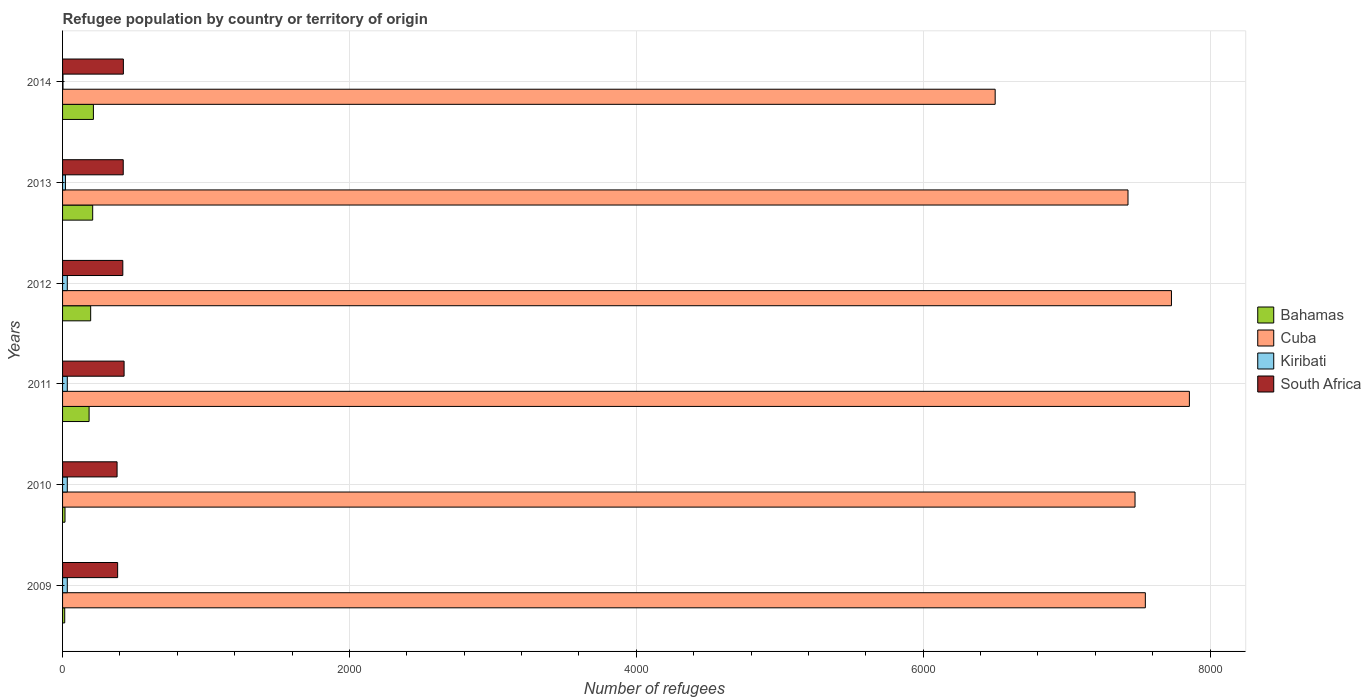How many groups of bars are there?
Offer a terse response. 6. Are the number of bars per tick equal to the number of legend labels?
Give a very brief answer. Yes. How many bars are there on the 4th tick from the bottom?
Give a very brief answer. 4. What is the label of the 2nd group of bars from the top?
Your answer should be compact. 2013. In how many cases, is the number of bars for a given year not equal to the number of legend labels?
Your answer should be very brief. 0. What is the number of refugees in South Africa in 2014?
Keep it short and to the point. 424. Across all years, what is the maximum number of refugees in Bahamas?
Make the answer very short. 215. Across all years, what is the minimum number of refugees in Cuba?
Your answer should be very brief. 6502. In which year was the number of refugees in Bahamas maximum?
Provide a short and direct response. 2014. What is the total number of refugees in Kiribati in the graph?
Keep it short and to the point. 155. What is the difference between the number of refugees in Bahamas in 2009 and that in 2010?
Your answer should be very brief. -2. What is the difference between the number of refugees in Cuba in 2014 and the number of refugees in Bahamas in 2013?
Ensure brevity in your answer.  6292. What is the average number of refugees in Cuba per year?
Your response must be concise. 7423.83. In the year 2012, what is the difference between the number of refugees in Kiribati and number of refugees in Bahamas?
Your answer should be compact. -163. In how many years, is the number of refugees in South Africa greater than 800 ?
Ensure brevity in your answer.  0. What is the ratio of the number of refugees in South Africa in 2009 to that in 2011?
Keep it short and to the point. 0.9. What is the difference between the highest and the second highest number of refugees in Cuba?
Ensure brevity in your answer.  125. What is the difference between the highest and the lowest number of refugees in South Africa?
Give a very brief answer. 49. In how many years, is the number of refugees in Kiribati greater than the average number of refugees in Kiribati taken over all years?
Provide a succinct answer. 4. What does the 2nd bar from the top in 2013 represents?
Provide a short and direct response. Kiribati. What does the 4th bar from the bottom in 2014 represents?
Offer a terse response. South Africa. Is it the case that in every year, the sum of the number of refugees in Cuba and number of refugees in South Africa is greater than the number of refugees in Bahamas?
Provide a succinct answer. Yes. What is the difference between two consecutive major ticks on the X-axis?
Make the answer very short. 2000. Does the graph contain any zero values?
Offer a terse response. No. Where does the legend appear in the graph?
Keep it short and to the point. Center right. How many legend labels are there?
Provide a short and direct response. 4. What is the title of the graph?
Your response must be concise. Refugee population by country or territory of origin. What is the label or title of the X-axis?
Give a very brief answer. Number of refugees. What is the Number of refugees in Bahamas in 2009?
Provide a short and direct response. 15. What is the Number of refugees in Cuba in 2009?
Provide a succinct answer. 7549. What is the Number of refugees in Kiribati in 2009?
Offer a terse response. 33. What is the Number of refugees of South Africa in 2009?
Provide a short and direct response. 384. What is the Number of refugees of Bahamas in 2010?
Provide a short and direct response. 17. What is the Number of refugees of Cuba in 2010?
Give a very brief answer. 7477. What is the Number of refugees in Kiribati in 2010?
Your answer should be compact. 33. What is the Number of refugees of South Africa in 2010?
Your answer should be very brief. 380. What is the Number of refugees in Bahamas in 2011?
Make the answer very short. 185. What is the Number of refugees in Cuba in 2011?
Ensure brevity in your answer.  7856. What is the Number of refugees in South Africa in 2011?
Provide a succinct answer. 429. What is the Number of refugees in Bahamas in 2012?
Give a very brief answer. 196. What is the Number of refugees in Cuba in 2012?
Give a very brief answer. 7731. What is the Number of refugees in South Africa in 2012?
Provide a succinct answer. 420. What is the Number of refugees of Bahamas in 2013?
Your answer should be very brief. 210. What is the Number of refugees of Cuba in 2013?
Provide a short and direct response. 7428. What is the Number of refugees of South Africa in 2013?
Make the answer very short. 423. What is the Number of refugees in Bahamas in 2014?
Provide a short and direct response. 215. What is the Number of refugees in Cuba in 2014?
Provide a succinct answer. 6502. What is the Number of refugees in Kiribati in 2014?
Keep it short and to the point. 3. What is the Number of refugees of South Africa in 2014?
Offer a terse response. 424. Across all years, what is the maximum Number of refugees in Bahamas?
Give a very brief answer. 215. Across all years, what is the maximum Number of refugees in Cuba?
Your answer should be very brief. 7856. Across all years, what is the maximum Number of refugees in South Africa?
Provide a succinct answer. 429. Across all years, what is the minimum Number of refugees of Cuba?
Your answer should be compact. 6502. Across all years, what is the minimum Number of refugees of South Africa?
Offer a terse response. 380. What is the total Number of refugees in Bahamas in the graph?
Your answer should be very brief. 838. What is the total Number of refugees of Cuba in the graph?
Provide a succinct answer. 4.45e+04. What is the total Number of refugees in Kiribati in the graph?
Provide a succinct answer. 155. What is the total Number of refugees in South Africa in the graph?
Your response must be concise. 2460. What is the difference between the Number of refugees of Kiribati in 2009 and that in 2010?
Offer a very short reply. 0. What is the difference between the Number of refugees in South Africa in 2009 and that in 2010?
Give a very brief answer. 4. What is the difference between the Number of refugees of Bahamas in 2009 and that in 2011?
Your response must be concise. -170. What is the difference between the Number of refugees of Cuba in 2009 and that in 2011?
Provide a succinct answer. -307. What is the difference between the Number of refugees of South Africa in 2009 and that in 2011?
Provide a short and direct response. -45. What is the difference between the Number of refugees in Bahamas in 2009 and that in 2012?
Offer a very short reply. -181. What is the difference between the Number of refugees in Cuba in 2009 and that in 2012?
Make the answer very short. -182. What is the difference between the Number of refugees in South Africa in 2009 and that in 2012?
Ensure brevity in your answer.  -36. What is the difference between the Number of refugees of Bahamas in 2009 and that in 2013?
Offer a terse response. -195. What is the difference between the Number of refugees in Cuba in 2009 and that in 2013?
Make the answer very short. 121. What is the difference between the Number of refugees in Kiribati in 2009 and that in 2013?
Provide a short and direct response. 13. What is the difference between the Number of refugees of South Africa in 2009 and that in 2013?
Ensure brevity in your answer.  -39. What is the difference between the Number of refugees of Bahamas in 2009 and that in 2014?
Give a very brief answer. -200. What is the difference between the Number of refugees of Cuba in 2009 and that in 2014?
Make the answer very short. 1047. What is the difference between the Number of refugees of Kiribati in 2009 and that in 2014?
Provide a succinct answer. 30. What is the difference between the Number of refugees in Bahamas in 2010 and that in 2011?
Offer a very short reply. -168. What is the difference between the Number of refugees in Cuba in 2010 and that in 2011?
Your answer should be very brief. -379. What is the difference between the Number of refugees in South Africa in 2010 and that in 2011?
Your answer should be very brief. -49. What is the difference between the Number of refugees of Bahamas in 2010 and that in 2012?
Your response must be concise. -179. What is the difference between the Number of refugees in Cuba in 2010 and that in 2012?
Offer a terse response. -254. What is the difference between the Number of refugees of South Africa in 2010 and that in 2012?
Ensure brevity in your answer.  -40. What is the difference between the Number of refugees of Bahamas in 2010 and that in 2013?
Your answer should be compact. -193. What is the difference between the Number of refugees of Cuba in 2010 and that in 2013?
Give a very brief answer. 49. What is the difference between the Number of refugees of South Africa in 2010 and that in 2013?
Offer a very short reply. -43. What is the difference between the Number of refugees in Bahamas in 2010 and that in 2014?
Ensure brevity in your answer.  -198. What is the difference between the Number of refugees of Cuba in 2010 and that in 2014?
Give a very brief answer. 975. What is the difference between the Number of refugees in Kiribati in 2010 and that in 2014?
Keep it short and to the point. 30. What is the difference between the Number of refugees in South Africa in 2010 and that in 2014?
Provide a succinct answer. -44. What is the difference between the Number of refugees in Cuba in 2011 and that in 2012?
Provide a succinct answer. 125. What is the difference between the Number of refugees in Bahamas in 2011 and that in 2013?
Keep it short and to the point. -25. What is the difference between the Number of refugees of Cuba in 2011 and that in 2013?
Offer a very short reply. 428. What is the difference between the Number of refugees of Kiribati in 2011 and that in 2013?
Make the answer very short. 13. What is the difference between the Number of refugees in South Africa in 2011 and that in 2013?
Offer a very short reply. 6. What is the difference between the Number of refugees in Bahamas in 2011 and that in 2014?
Offer a very short reply. -30. What is the difference between the Number of refugees of Cuba in 2011 and that in 2014?
Provide a short and direct response. 1354. What is the difference between the Number of refugees in South Africa in 2011 and that in 2014?
Provide a succinct answer. 5. What is the difference between the Number of refugees in Bahamas in 2012 and that in 2013?
Ensure brevity in your answer.  -14. What is the difference between the Number of refugees in Cuba in 2012 and that in 2013?
Keep it short and to the point. 303. What is the difference between the Number of refugees of South Africa in 2012 and that in 2013?
Offer a very short reply. -3. What is the difference between the Number of refugees of Bahamas in 2012 and that in 2014?
Your response must be concise. -19. What is the difference between the Number of refugees of Cuba in 2012 and that in 2014?
Your response must be concise. 1229. What is the difference between the Number of refugees of Kiribati in 2012 and that in 2014?
Provide a succinct answer. 30. What is the difference between the Number of refugees in South Africa in 2012 and that in 2014?
Your answer should be compact. -4. What is the difference between the Number of refugees of Cuba in 2013 and that in 2014?
Give a very brief answer. 926. What is the difference between the Number of refugees in Bahamas in 2009 and the Number of refugees in Cuba in 2010?
Offer a very short reply. -7462. What is the difference between the Number of refugees in Bahamas in 2009 and the Number of refugees in Kiribati in 2010?
Give a very brief answer. -18. What is the difference between the Number of refugees in Bahamas in 2009 and the Number of refugees in South Africa in 2010?
Your answer should be compact. -365. What is the difference between the Number of refugees in Cuba in 2009 and the Number of refugees in Kiribati in 2010?
Ensure brevity in your answer.  7516. What is the difference between the Number of refugees in Cuba in 2009 and the Number of refugees in South Africa in 2010?
Your answer should be very brief. 7169. What is the difference between the Number of refugees of Kiribati in 2009 and the Number of refugees of South Africa in 2010?
Make the answer very short. -347. What is the difference between the Number of refugees in Bahamas in 2009 and the Number of refugees in Cuba in 2011?
Offer a terse response. -7841. What is the difference between the Number of refugees in Bahamas in 2009 and the Number of refugees in Kiribati in 2011?
Provide a short and direct response. -18. What is the difference between the Number of refugees of Bahamas in 2009 and the Number of refugees of South Africa in 2011?
Ensure brevity in your answer.  -414. What is the difference between the Number of refugees in Cuba in 2009 and the Number of refugees in Kiribati in 2011?
Offer a terse response. 7516. What is the difference between the Number of refugees of Cuba in 2009 and the Number of refugees of South Africa in 2011?
Your answer should be compact. 7120. What is the difference between the Number of refugees in Kiribati in 2009 and the Number of refugees in South Africa in 2011?
Provide a succinct answer. -396. What is the difference between the Number of refugees in Bahamas in 2009 and the Number of refugees in Cuba in 2012?
Offer a very short reply. -7716. What is the difference between the Number of refugees of Bahamas in 2009 and the Number of refugees of Kiribati in 2012?
Offer a terse response. -18. What is the difference between the Number of refugees of Bahamas in 2009 and the Number of refugees of South Africa in 2012?
Offer a terse response. -405. What is the difference between the Number of refugees of Cuba in 2009 and the Number of refugees of Kiribati in 2012?
Provide a succinct answer. 7516. What is the difference between the Number of refugees in Cuba in 2009 and the Number of refugees in South Africa in 2012?
Provide a short and direct response. 7129. What is the difference between the Number of refugees in Kiribati in 2009 and the Number of refugees in South Africa in 2012?
Give a very brief answer. -387. What is the difference between the Number of refugees in Bahamas in 2009 and the Number of refugees in Cuba in 2013?
Offer a very short reply. -7413. What is the difference between the Number of refugees of Bahamas in 2009 and the Number of refugees of Kiribati in 2013?
Provide a succinct answer. -5. What is the difference between the Number of refugees in Bahamas in 2009 and the Number of refugees in South Africa in 2013?
Your response must be concise. -408. What is the difference between the Number of refugees of Cuba in 2009 and the Number of refugees of Kiribati in 2013?
Your answer should be compact. 7529. What is the difference between the Number of refugees in Cuba in 2009 and the Number of refugees in South Africa in 2013?
Provide a succinct answer. 7126. What is the difference between the Number of refugees in Kiribati in 2009 and the Number of refugees in South Africa in 2013?
Make the answer very short. -390. What is the difference between the Number of refugees in Bahamas in 2009 and the Number of refugees in Cuba in 2014?
Give a very brief answer. -6487. What is the difference between the Number of refugees of Bahamas in 2009 and the Number of refugees of Kiribati in 2014?
Your answer should be compact. 12. What is the difference between the Number of refugees of Bahamas in 2009 and the Number of refugees of South Africa in 2014?
Offer a very short reply. -409. What is the difference between the Number of refugees in Cuba in 2009 and the Number of refugees in Kiribati in 2014?
Provide a succinct answer. 7546. What is the difference between the Number of refugees in Cuba in 2009 and the Number of refugees in South Africa in 2014?
Keep it short and to the point. 7125. What is the difference between the Number of refugees of Kiribati in 2009 and the Number of refugees of South Africa in 2014?
Give a very brief answer. -391. What is the difference between the Number of refugees in Bahamas in 2010 and the Number of refugees in Cuba in 2011?
Your answer should be very brief. -7839. What is the difference between the Number of refugees in Bahamas in 2010 and the Number of refugees in South Africa in 2011?
Make the answer very short. -412. What is the difference between the Number of refugees in Cuba in 2010 and the Number of refugees in Kiribati in 2011?
Ensure brevity in your answer.  7444. What is the difference between the Number of refugees in Cuba in 2010 and the Number of refugees in South Africa in 2011?
Provide a short and direct response. 7048. What is the difference between the Number of refugees in Kiribati in 2010 and the Number of refugees in South Africa in 2011?
Your response must be concise. -396. What is the difference between the Number of refugees of Bahamas in 2010 and the Number of refugees of Cuba in 2012?
Your response must be concise. -7714. What is the difference between the Number of refugees in Bahamas in 2010 and the Number of refugees in Kiribati in 2012?
Provide a succinct answer. -16. What is the difference between the Number of refugees in Bahamas in 2010 and the Number of refugees in South Africa in 2012?
Provide a short and direct response. -403. What is the difference between the Number of refugees in Cuba in 2010 and the Number of refugees in Kiribati in 2012?
Your answer should be compact. 7444. What is the difference between the Number of refugees of Cuba in 2010 and the Number of refugees of South Africa in 2012?
Ensure brevity in your answer.  7057. What is the difference between the Number of refugees in Kiribati in 2010 and the Number of refugees in South Africa in 2012?
Provide a short and direct response. -387. What is the difference between the Number of refugees in Bahamas in 2010 and the Number of refugees in Cuba in 2013?
Your answer should be very brief. -7411. What is the difference between the Number of refugees of Bahamas in 2010 and the Number of refugees of Kiribati in 2013?
Your answer should be very brief. -3. What is the difference between the Number of refugees in Bahamas in 2010 and the Number of refugees in South Africa in 2013?
Your response must be concise. -406. What is the difference between the Number of refugees of Cuba in 2010 and the Number of refugees of Kiribati in 2013?
Your answer should be compact. 7457. What is the difference between the Number of refugees in Cuba in 2010 and the Number of refugees in South Africa in 2013?
Keep it short and to the point. 7054. What is the difference between the Number of refugees of Kiribati in 2010 and the Number of refugees of South Africa in 2013?
Make the answer very short. -390. What is the difference between the Number of refugees in Bahamas in 2010 and the Number of refugees in Cuba in 2014?
Your answer should be compact. -6485. What is the difference between the Number of refugees in Bahamas in 2010 and the Number of refugees in Kiribati in 2014?
Keep it short and to the point. 14. What is the difference between the Number of refugees of Bahamas in 2010 and the Number of refugees of South Africa in 2014?
Your answer should be compact. -407. What is the difference between the Number of refugees of Cuba in 2010 and the Number of refugees of Kiribati in 2014?
Keep it short and to the point. 7474. What is the difference between the Number of refugees in Cuba in 2010 and the Number of refugees in South Africa in 2014?
Your answer should be very brief. 7053. What is the difference between the Number of refugees of Kiribati in 2010 and the Number of refugees of South Africa in 2014?
Your answer should be compact. -391. What is the difference between the Number of refugees of Bahamas in 2011 and the Number of refugees of Cuba in 2012?
Make the answer very short. -7546. What is the difference between the Number of refugees of Bahamas in 2011 and the Number of refugees of Kiribati in 2012?
Make the answer very short. 152. What is the difference between the Number of refugees in Bahamas in 2011 and the Number of refugees in South Africa in 2012?
Keep it short and to the point. -235. What is the difference between the Number of refugees of Cuba in 2011 and the Number of refugees of Kiribati in 2012?
Provide a succinct answer. 7823. What is the difference between the Number of refugees of Cuba in 2011 and the Number of refugees of South Africa in 2012?
Offer a very short reply. 7436. What is the difference between the Number of refugees of Kiribati in 2011 and the Number of refugees of South Africa in 2012?
Your answer should be compact. -387. What is the difference between the Number of refugees in Bahamas in 2011 and the Number of refugees in Cuba in 2013?
Provide a succinct answer. -7243. What is the difference between the Number of refugees in Bahamas in 2011 and the Number of refugees in Kiribati in 2013?
Provide a succinct answer. 165. What is the difference between the Number of refugees of Bahamas in 2011 and the Number of refugees of South Africa in 2013?
Your response must be concise. -238. What is the difference between the Number of refugees in Cuba in 2011 and the Number of refugees in Kiribati in 2013?
Your answer should be compact. 7836. What is the difference between the Number of refugees in Cuba in 2011 and the Number of refugees in South Africa in 2013?
Your response must be concise. 7433. What is the difference between the Number of refugees in Kiribati in 2011 and the Number of refugees in South Africa in 2013?
Your response must be concise. -390. What is the difference between the Number of refugees in Bahamas in 2011 and the Number of refugees in Cuba in 2014?
Keep it short and to the point. -6317. What is the difference between the Number of refugees in Bahamas in 2011 and the Number of refugees in Kiribati in 2014?
Provide a succinct answer. 182. What is the difference between the Number of refugees in Bahamas in 2011 and the Number of refugees in South Africa in 2014?
Keep it short and to the point. -239. What is the difference between the Number of refugees in Cuba in 2011 and the Number of refugees in Kiribati in 2014?
Your answer should be compact. 7853. What is the difference between the Number of refugees in Cuba in 2011 and the Number of refugees in South Africa in 2014?
Keep it short and to the point. 7432. What is the difference between the Number of refugees in Kiribati in 2011 and the Number of refugees in South Africa in 2014?
Ensure brevity in your answer.  -391. What is the difference between the Number of refugees of Bahamas in 2012 and the Number of refugees of Cuba in 2013?
Make the answer very short. -7232. What is the difference between the Number of refugees of Bahamas in 2012 and the Number of refugees of Kiribati in 2013?
Provide a short and direct response. 176. What is the difference between the Number of refugees of Bahamas in 2012 and the Number of refugees of South Africa in 2013?
Your answer should be very brief. -227. What is the difference between the Number of refugees in Cuba in 2012 and the Number of refugees in Kiribati in 2013?
Your answer should be compact. 7711. What is the difference between the Number of refugees in Cuba in 2012 and the Number of refugees in South Africa in 2013?
Ensure brevity in your answer.  7308. What is the difference between the Number of refugees of Kiribati in 2012 and the Number of refugees of South Africa in 2013?
Ensure brevity in your answer.  -390. What is the difference between the Number of refugees in Bahamas in 2012 and the Number of refugees in Cuba in 2014?
Your answer should be compact. -6306. What is the difference between the Number of refugees in Bahamas in 2012 and the Number of refugees in Kiribati in 2014?
Keep it short and to the point. 193. What is the difference between the Number of refugees of Bahamas in 2012 and the Number of refugees of South Africa in 2014?
Make the answer very short. -228. What is the difference between the Number of refugees in Cuba in 2012 and the Number of refugees in Kiribati in 2014?
Give a very brief answer. 7728. What is the difference between the Number of refugees in Cuba in 2012 and the Number of refugees in South Africa in 2014?
Give a very brief answer. 7307. What is the difference between the Number of refugees in Kiribati in 2012 and the Number of refugees in South Africa in 2014?
Your answer should be compact. -391. What is the difference between the Number of refugees in Bahamas in 2013 and the Number of refugees in Cuba in 2014?
Make the answer very short. -6292. What is the difference between the Number of refugees of Bahamas in 2013 and the Number of refugees of Kiribati in 2014?
Make the answer very short. 207. What is the difference between the Number of refugees in Bahamas in 2013 and the Number of refugees in South Africa in 2014?
Make the answer very short. -214. What is the difference between the Number of refugees of Cuba in 2013 and the Number of refugees of Kiribati in 2014?
Give a very brief answer. 7425. What is the difference between the Number of refugees in Cuba in 2013 and the Number of refugees in South Africa in 2014?
Provide a short and direct response. 7004. What is the difference between the Number of refugees of Kiribati in 2013 and the Number of refugees of South Africa in 2014?
Keep it short and to the point. -404. What is the average Number of refugees of Bahamas per year?
Offer a very short reply. 139.67. What is the average Number of refugees of Cuba per year?
Offer a very short reply. 7423.83. What is the average Number of refugees in Kiribati per year?
Give a very brief answer. 25.83. What is the average Number of refugees of South Africa per year?
Keep it short and to the point. 410. In the year 2009, what is the difference between the Number of refugees of Bahamas and Number of refugees of Cuba?
Ensure brevity in your answer.  -7534. In the year 2009, what is the difference between the Number of refugees of Bahamas and Number of refugees of South Africa?
Provide a short and direct response. -369. In the year 2009, what is the difference between the Number of refugees of Cuba and Number of refugees of Kiribati?
Your answer should be compact. 7516. In the year 2009, what is the difference between the Number of refugees of Cuba and Number of refugees of South Africa?
Your response must be concise. 7165. In the year 2009, what is the difference between the Number of refugees in Kiribati and Number of refugees in South Africa?
Your answer should be compact. -351. In the year 2010, what is the difference between the Number of refugees in Bahamas and Number of refugees in Cuba?
Give a very brief answer. -7460. In the year 2010, what is the difference between the Number of refugees in Bahamas and Number of refugees in Kiribati?
Provide a succinct answer. -16. In the year 2010, what is the difference between the Number of refugees in Bahamas and Number of refugees in South Africa?
Ensure brevity in your answer.  -363. In the year 2010, what is the difference between the Number of refugees in Cuba and Number of refugees in Kiribati?
Provide a succinct answer. 7444. In the year 2010, what is the difference between the Number of refugees in Cuba and Number of refugees in South Africa?
Offer a terse response. 7097. In the year 2010, what is the difference between the Number of refugees of Kiribati and Number of refugees of South Africa?
Provide a short and direct response. -347. In the year 2011, what is the difference between the Number of refugees of Bahamas and Number of refugees of Cuba?
Provide a short and direct response. -7671. In the year 2011, what is the difference between the Number of refugees of Bahamas and Number of refugees of Kiribati?
Offer a very short reply. 152. In the year 2011, what is the difference between the Number of refugees of Bahamas and Number of refugees of South Africa?
Ensure brevity in your answer.  -244. In the year 2011, what is the difference between the Number of refugees of Cuba and Number of refugees of Kiribati?
Your answer should be very brief. 7823. In the year 2011, what is the difference between the Number of refugees of Cuba and Number of refugees of South Africa?
Offer a very short reply. 7427. In the year 2011, what is the difference between the Number of refugees in Kiribati and Number of refugees in South Africa?
Make the answer very short. -396. In the year 2012, what is the difference between the Number of refugees in Bahamas and Number of refugees in Cuba?
Offer a terse response. -7535. In the year 2012, what is the difference between the Number of refugees in Bahamas and Number of refugees in Kiribati?
Make the answer very short. 163. In the year 2012, what is the difference between the Number of refugees in Bahamas and Number of refugees in South Africa?
Ensure brevity in your answer.  -224. In the year 2012, what is the difference between the Number of refugees in Cuba and Number of refugees in Kiribati?
Keep it short and to the point. 7698. In the year 2012, what is the difference between the Number of refugees in Cuba and Number of refugees in South Africa?
Give a very brief answer. 7311. In the year 2012, what is the difference between the Number of refugees in Kiribati and Number of refugees in South Africa?
Ensure brevity in your answer.  -387. In the year 2013, what is the difference between the Number of refugees in Bahamas and Number of refugees in Cuba?
Your response must be concise. -7218. In the year 2013, what is the difference between the Number of refugees in Bahamas and Number of refugees in Kiribati?
Your answer should be very brief. 190. In the year 2013, what is the difference between the Number of refugees in Bahamas and Number of refugees in South Africa?
Provide a short and direct response. -213. In the year 2013, what is the difference between the Number of refugees in Cuba and Number of refugees in Kiribati?
Your answer should be compact. 7408. In the year 2013, what is the difference between the Number of refugees in Cuba and Number of refugees in South Africa?
Offer a terse response. 7005. In the year 2013, what is the difference between the Number of refugees of Kiribati and Number of refugees of South Africa?
Your answer should be compact. -403. In the year 2014, what is the difference between the Number of refugees in Bahamas and Number of refugees in Cuba?
Ensure brevity in your answer.  -6287. In the year 2014, what is the difference between the Number of refugees of Bahamas and Number of refugees of Kiribati?
Offer a terse response. 212. In the year 2014, what is the difference between the Number of refugees of Bahamas and Number of refugees of South Africa?
Your answer should be very brief. -209. In the year 2014, what is the difference between the Number of refugees of Cuba and Number of refugees of Kiribati?
Offer a very short reply. 6499. In the year 2014, what is the difference between the Number of refugees in Cuba and Number of refugees in South Africa?
Offer a terse response. 6078. In the year 2014, what is the difference between the Number of refugees in Kiribati and Number of refugees in South Africa?
Provide a succinct answer. -421. What is the ratio of the Number of refugees of Bahamas in 2009 to that in 2010?
Make the answer very short. 0.88. What is the ratio of the Number of refugees in Cuba in 2009 to that in 2010?
Your answer should be very brief. 1.01. What is the ratio of the Number of refugees in Kiribati in 2009 to that in 2010?
Give a very brief answer. 1. What is the ratio of the Number of refugees of South Africa in 2009 to that in 2010?
Offer a terse response. 1.01. What is the ratio of the Number of refugees of Bahamas in 2009 to that in 2011?
Offer a terse response. 0.08. What is the ratio of the Number of refugees in Cuba in 2009 to that in 2011?
Ensure brevity in your answer.  0.96. What is the ratio of the Number of refugees in Kiribati in 2009 to that in 2011?
Provide a succinct answer. 1. What is the ratio of the Number of refugees of South Africa in 2009 to that in 2011?
Make the answer very short. 0.9. What is the ratio of the Number of refugees in Bahamas in 2009 to that in 2012?
Offer a very short reply. 0.08. What is the ratio of the Number of refugees of Cuba in 2009 to that in 2012?
Ensure brevity in your answer.  0.98. What is the ratio of the Number of refugees in South Africa in 2009 to that in 2012?
Your response must be concise. 0.91. What is the ratio of the Number of refugees of Bahamas in 2009 to that in 2013?
Provide a short and direct response. 0.07. What is the ratio of the Number of refugees of Cuba in 2009 to that in 2013?
Provide a succinct answer. 1.02. What is the ratio of the Number of refugees of Kiribati in 2009 to that in 2013?
Your answer should be very brief. 1.65. What is the ratio of the Number of refugees in South Africa in 2009 to that in 2013?
Your answer should be compact. 0.91. What is the ratio of the Number of refugees of Bahamas in 2009 to that in 2014?
Your answer should be very brief. 0.07. What is the ratio of the Number of refugees in Cuba in 2009 to that in 2014?
Provide a succinct answer. 1.16. What is the ratio of the Number of refugees in Kiribati in 2009 to that in 2014?
Your response must be concise. 11. What is the ratio of the Number of refugees of South Africa in 2009 to that in 2014?
Provide a short and direct response. 0.91. What is the ratio of the Number of refugees of Bahamas in 2010 to that in 2011?
Offer a terse response. 0.09. What is the ratio of the Number of refugees in Cuba in 2010 to that in 2011?
Offer a very short reply. 0.95. What is the ratio of the Number of refugees of Kiribati in 2010 to that in 2011?
Offer a terse response. 1. What is the ratio of the Number of refugees in South Africa in 2010 to that in 2011?
Give a very brief answer. 0.89. What is the ratio of the Number of refugees of Bahamas in 2010 to that in 2012?
Ensure brevity in your answer.  0.09. What is the ratio of the Number of refugees of Cuba in 2010 to that in 2012?
Your answer should be very brief. 0.97. What is the ratio of the Number of refugees of South Africa in 2010 to that in 2012?
Offer a terse response. 0.9. What is the ratio of the Number of refugees in Bahamas in 2010 to that in 2013?
Your answer should be very brief. 0.08. What is the ratio of the Number of refugees in Cuba in 2010 to that in 2013?
Your answer should be compact. 1.01. What is the ratio of the Number of refugees in Kiribati in 2010 to that in 2013?
Offer a very short reply. 1.65. What is the ratio of the Number of refugees in South Africa in 2010 to that in 2013?
Give a very brief answer. 0.9. What is the ratio of the Number of refugees of Bahamas in 2010 to that in 2014?
Offer a terse response. 0.08. What is the ratio of the Number of refugees of Cuba in 2010 to that in 2014?
Ensure brevity in your answer.  1.15. What is the ratio of the Number of refugees in South Africa in 2010 to that in 2014?
Offer a terse response. 0.9. What is the ratio of the Number of refugees of Bahamas in 2011 to that in 2012?
Keep it short and to the point. 0.94. What is the ratio of the Number of refugees of Cuba in 2011 to that in 2012?
Provide a short and direct response. 1.02. What is the ratio of the Number of refugees of South Africa in 2011 to that in 2012?
Your response must be concise. 1.02. What is the ratio of the Number of refugees in Bahamas in 2011 to that in 2013?
Provide a succinct answer. 0.88. What is the ratio of the Number of refugees of Cuba in 2011 to that in 2013?
Offer a very short reply. 1.06. What is the ratio of the Number of refugees in Kiribati in 2011 to that in 2013?
Give a very brief answer. 1.65. What is the ratio of the Number of refugees in South Africa in 2011 to that in 2013?
Your answer should be compact. 1.01. What is the ratio of the Number of refugees in Bahamas in 2011 to that in 2014?
Your answer should be very brief. 0.86. What is the ratio of the Number of refugees in Cuba in 2011 to that in 2014?
Ensure brevity in your answer.  1.21. What is the ratio of the Number of refugees of South Africa in 2011 to that in 2014?
Provide a short and direct response. 1.01. What is the ratio of the Number of refugees of Bahamas in 2012 to that in 2013?
Offer a very short reply. 0.93. What is the ratio of the Number of refugees in Cuba in 2012 to that in 2013?
Offer a very short reply. 1.04. What is the ratio of the Number of refugees of Kiribati in 2012 to that in 2013?
Your answer should be very brief. 1.65. What is the ratio of the Number of refugees of Bahamas in 2012 to that in 2014?
Provide a short and direct response. 0.91. What is the ratio of the Number of refugees of Cuba in 2012 to that in 2014?
Offer a very short reply. 1.19. What is the ratio of the Number of refugees of South Africa in 2012 to that in 2014?
Offer a terse response. 0.99. What is the ratio of the Number of refugees of Bahamas in 2013 to that in 2014?
Ensure brevity in your answer.  0.98. What is the ratio of the Number of refugees in Cuba in 2013 to that in 2014?
Keep it short and to the point. 1.14. What is the ratio of the Number of refugees of South Africa in 2013 to that in 2014?
Your answer should be very brief. 1. What is the difference between the highest and the second highest Number of refugees in Bahamas?
Make the answer very short. 5. What is the difference between the highest and the second highest Number of refugees of Cuba?
Keep it short and to the point. 125. What is the difference between the highest and the second highest Number of refugees in South Africa?
Provide a succinct answer. 5. What is the difference between the highest and the lowest Number of refugees of Cuba?
Offer a terse response. 1354. 